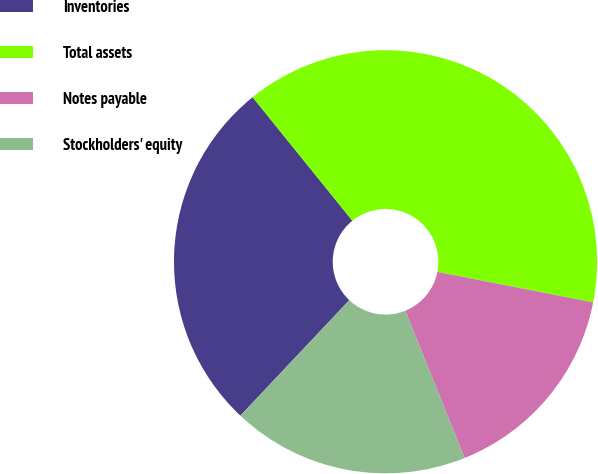Convert chart. <chart><loc_0><loc_0><loc_500><loc_500><pie_chart><fcel>Inventories<fcel>Total assets<fcel>Notes payable<fcel>Stockholders' equity<nl><fcel>27.15%<fcel>38.89%<fcel>15.83%<fcel>18.13%<nl></chart> 